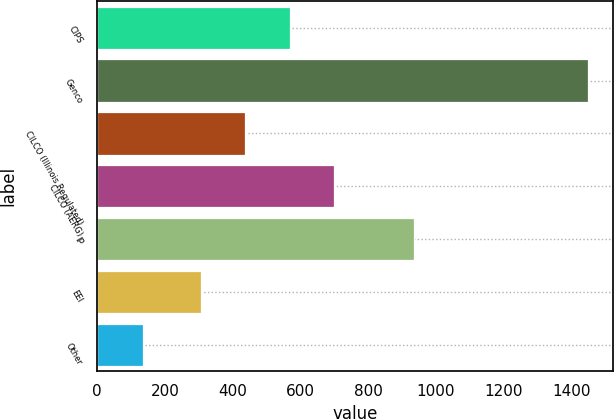Convert chart to OTSL. <chart><loc_0><loc_0><loc_500><loc_500><bar_chart><fcel>CIPS<fcel>Genco<fcel>CILCO (Illinois Regulated)<fcel>CILCO (AERG)<fcel>IP<fcel>EEI<fcel>Other<nl><fcel>568<fcel>1450<fcel>436.5<fcel>699.5<fcel>935<fcel>305<fcel>135<nl></chart> 